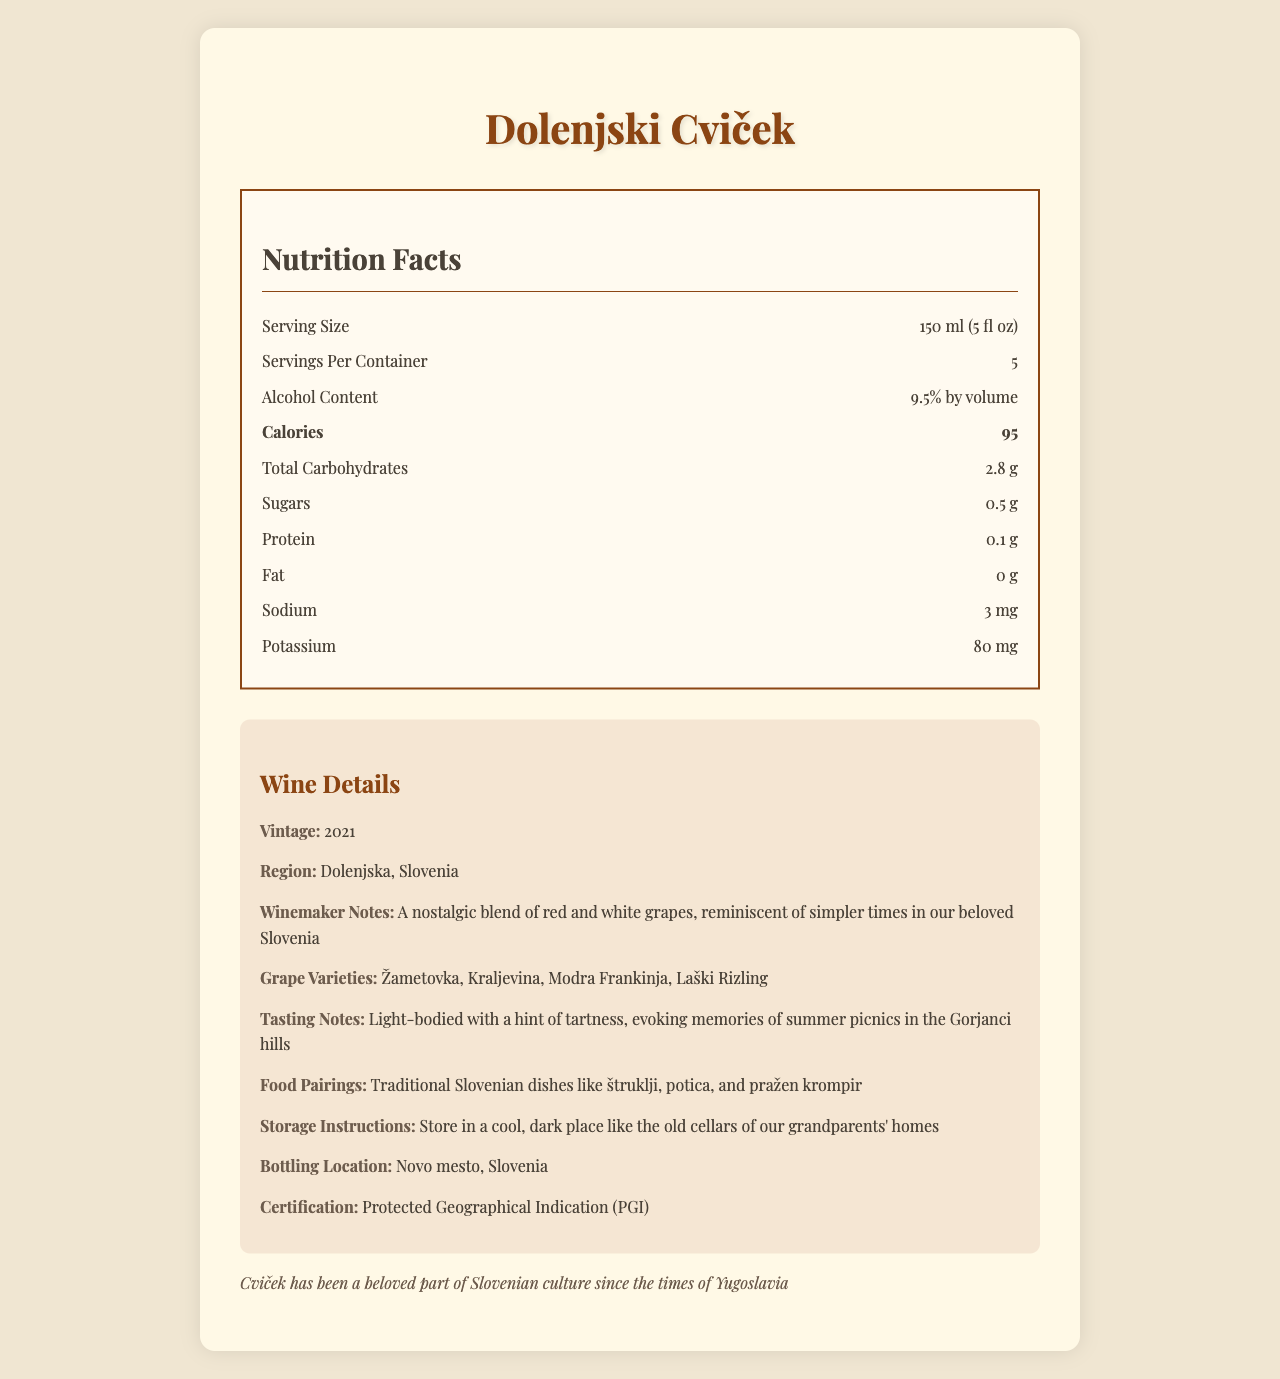what is the alcohol content of the wine? The alcohol content is specifically listed in the nutrition facts label section.
Answer: 9.5% by volume How many calories are in one serving of Dolenjski Cviček? The number of calories per serving is clearly mentioned in the nutrition facts under "Calories".
Answer: 95 What is the serving size for Dolenjski Cviček? The serving size is listed at the top of the nutrition facts, detailing the exact volume for one serving.
Answer: 150 ml (5 fl oz) How many grams of total carbohydrates are present in one serving? The total carbohydrates per serving is listed in the nutrition facts section under "Total Carbohydrates".
Answer: 2.8 g What is the protein content in one serving of this wine? The protein content is clearly mentioned in the nutrition facts section.
Answer: 0.1 g How much sodium does one serving of Dolenjski Cviček contain? Sodium content per serving is listed in the nutrition facts label.
Answer: 3 mg Which grape varieties are used in Dolenjski Cviček? The grape varieties are mentioned in the wine details section under "Grape Varieties".
Answer: Žametovka, Kraljevina, Modra Frankinja, Laški Rizling Where should you store the bottle of Dolenjski Cviček? A. In a warm place B. In a cool, dark place C. In a refrigerator D. In direct sunlight The storage instructions suggest storing the wine in a cool, dark place like old cellars.
Answer: B. In a cool, dark place How many servings are there in a container of Dolenjski Cviček? A. 3 B. 4 C. 5 D. 6 The document lists "Servings Per Container" as 5 in the nutrition facts section.
Answer: C. 5 Is there any fat content in Dolenjski Cviček? The nutrition facts indicate that the fat content is 0 g, meaning there is no fat in the wine.
Answer: No What year is the vintage of the Dolenjski Cviček mentioned in the document? The vintage year is specified in the wine details section under "Vintage".
Answer: 2021 Summarize the main idea presented in the document. The document aims to provide consumers with all the necessary information regarding the nutritional facts and characteristics of Dolenjski Cviček wine, evoking a sense of nostalgia associated with Slovenian culture.
Answer: The document provides detailed nutritional information and other specifics about Dolenjski Cviček wine, which includes its serving size, alcohol content, calorie count, and various other nutritional components. Additionally, it describes the wine's vintage, region, winemaker notes, grape varieties, tasting notes, food pairings, storage instructions, bottling location, and certification. What is the main winemaker's note shared in the document about Dolenjski Cviček? The winemaker's notes are described in the wine details section, highlighting the nostalgic qualities of the blend.
Answer: A nostalgic blend of red and white grapes, reminiscent of simpler times in our beloved Slovenia How much potassium is in one serving of this wine? The nutrition facts label specifies that there are 80 mg of potassium per serving.
Answer: 80 mg What food pairs well with Dolenjski Cviček according to the document? The food pairings are listed in the wine details section, suggesting traditional Slovenian dishes.
Answer: Traditional Slovenian dishes like štruklji, potica, and pražen krompir Can the exact location where the wine was bottled be found in the document? The bottling location is specified in the wine details section.
Answer: Yes, Novo mesto, Slovenia 